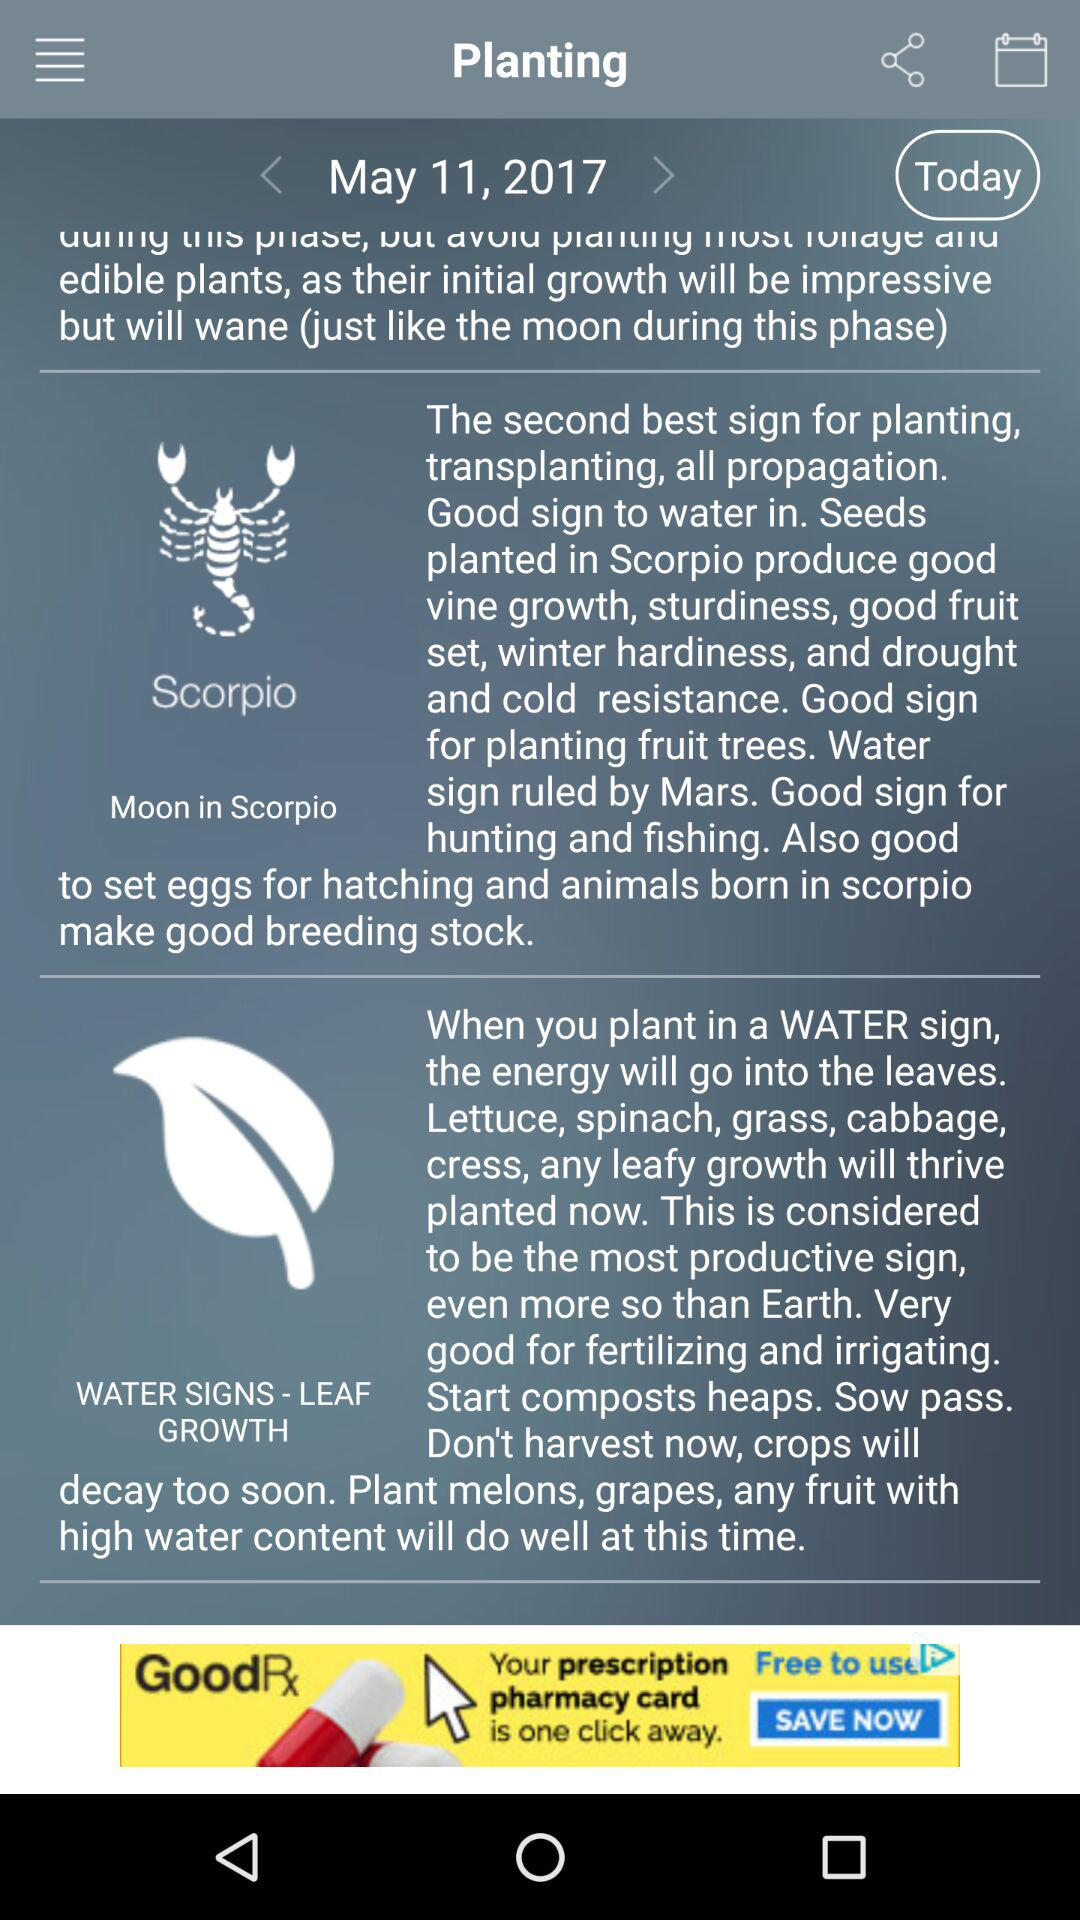What is today's date? Today's date is May 11, 2017. 